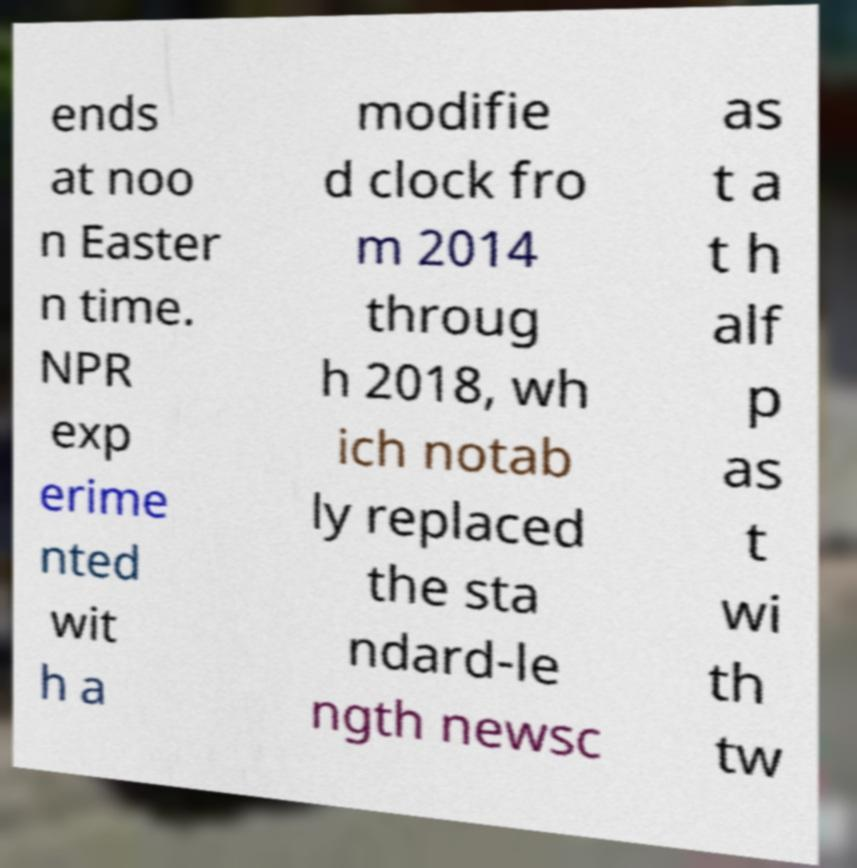For documentation purposes, I need the text within this image transcribed. Could you provide that? ends at noo n Easter n time. NPR exp erime nted wit h a modifie d clock fro m 2014 throug h 2018, wh ich notab ly replaced the sta ndard-le ngth newsc as t a t h alf p as t wi th tw 